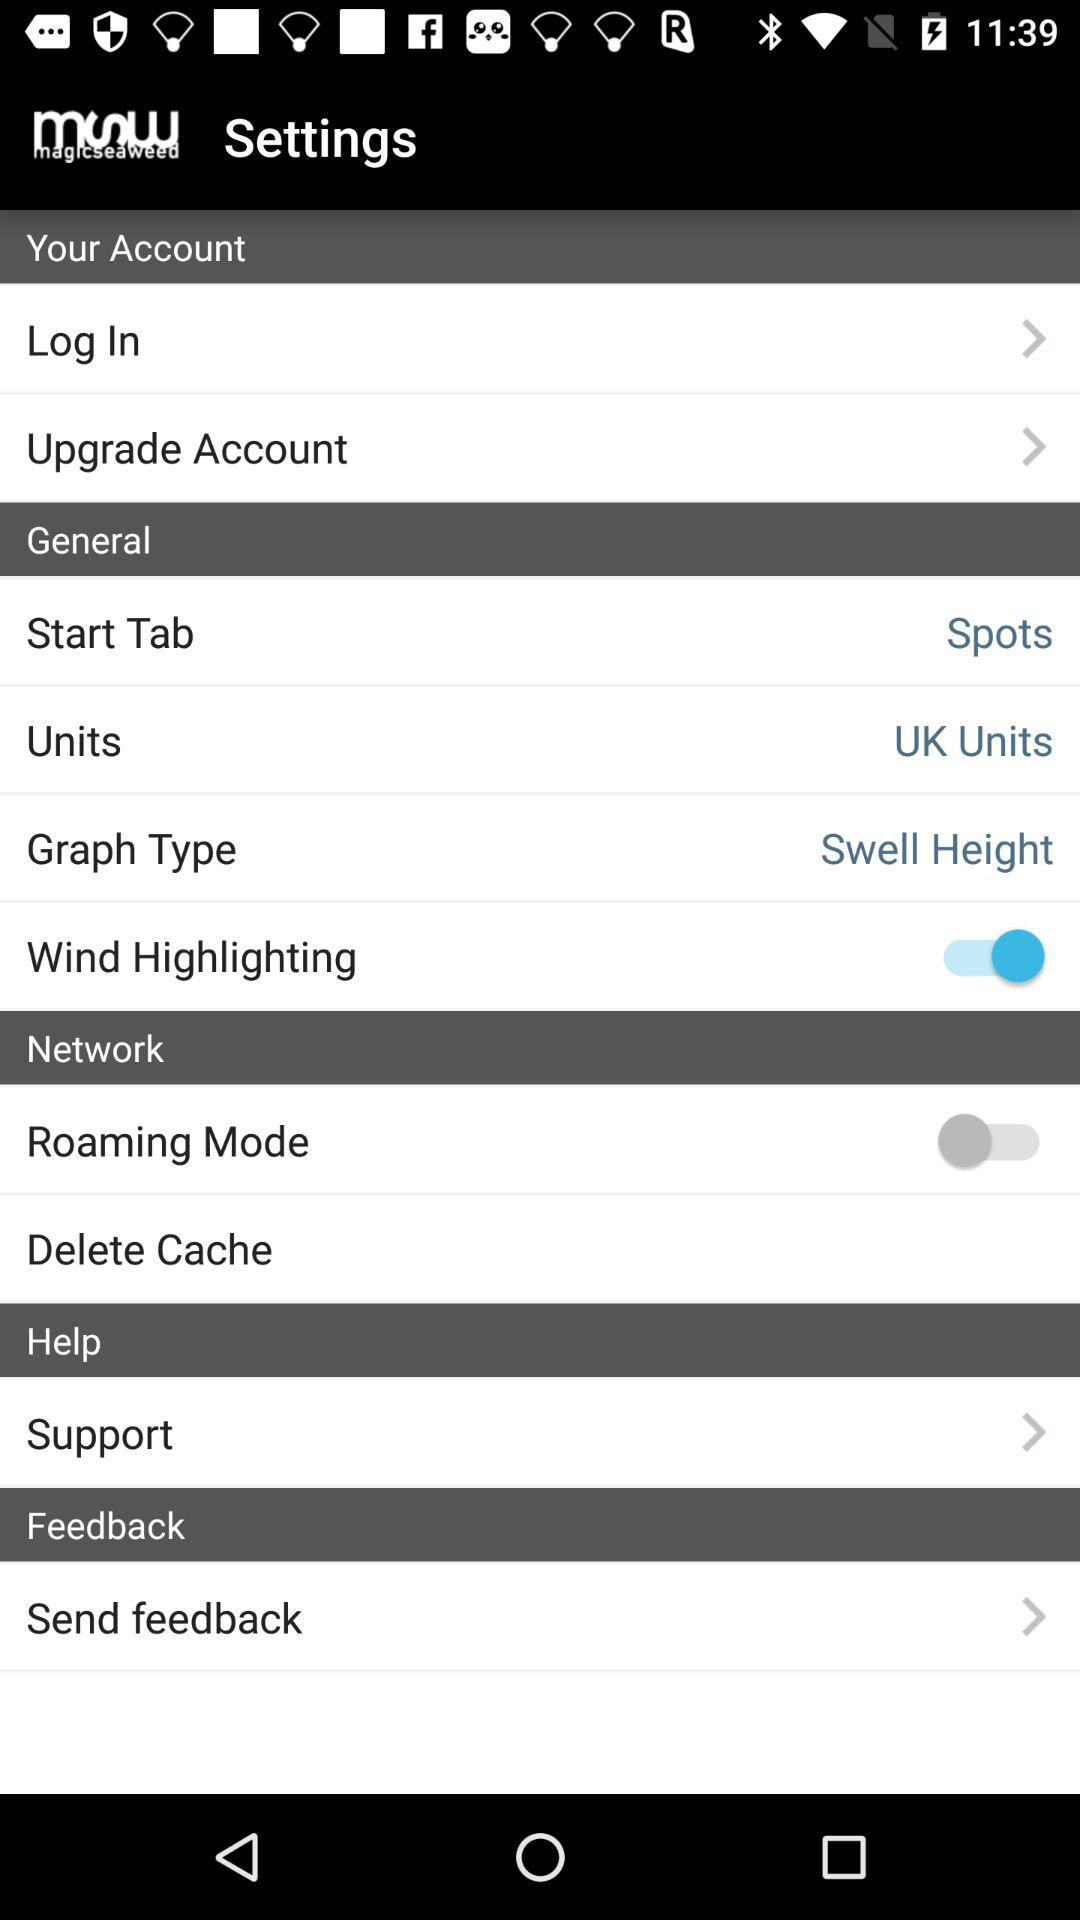What is the start tab? The start tab is "Spots". 